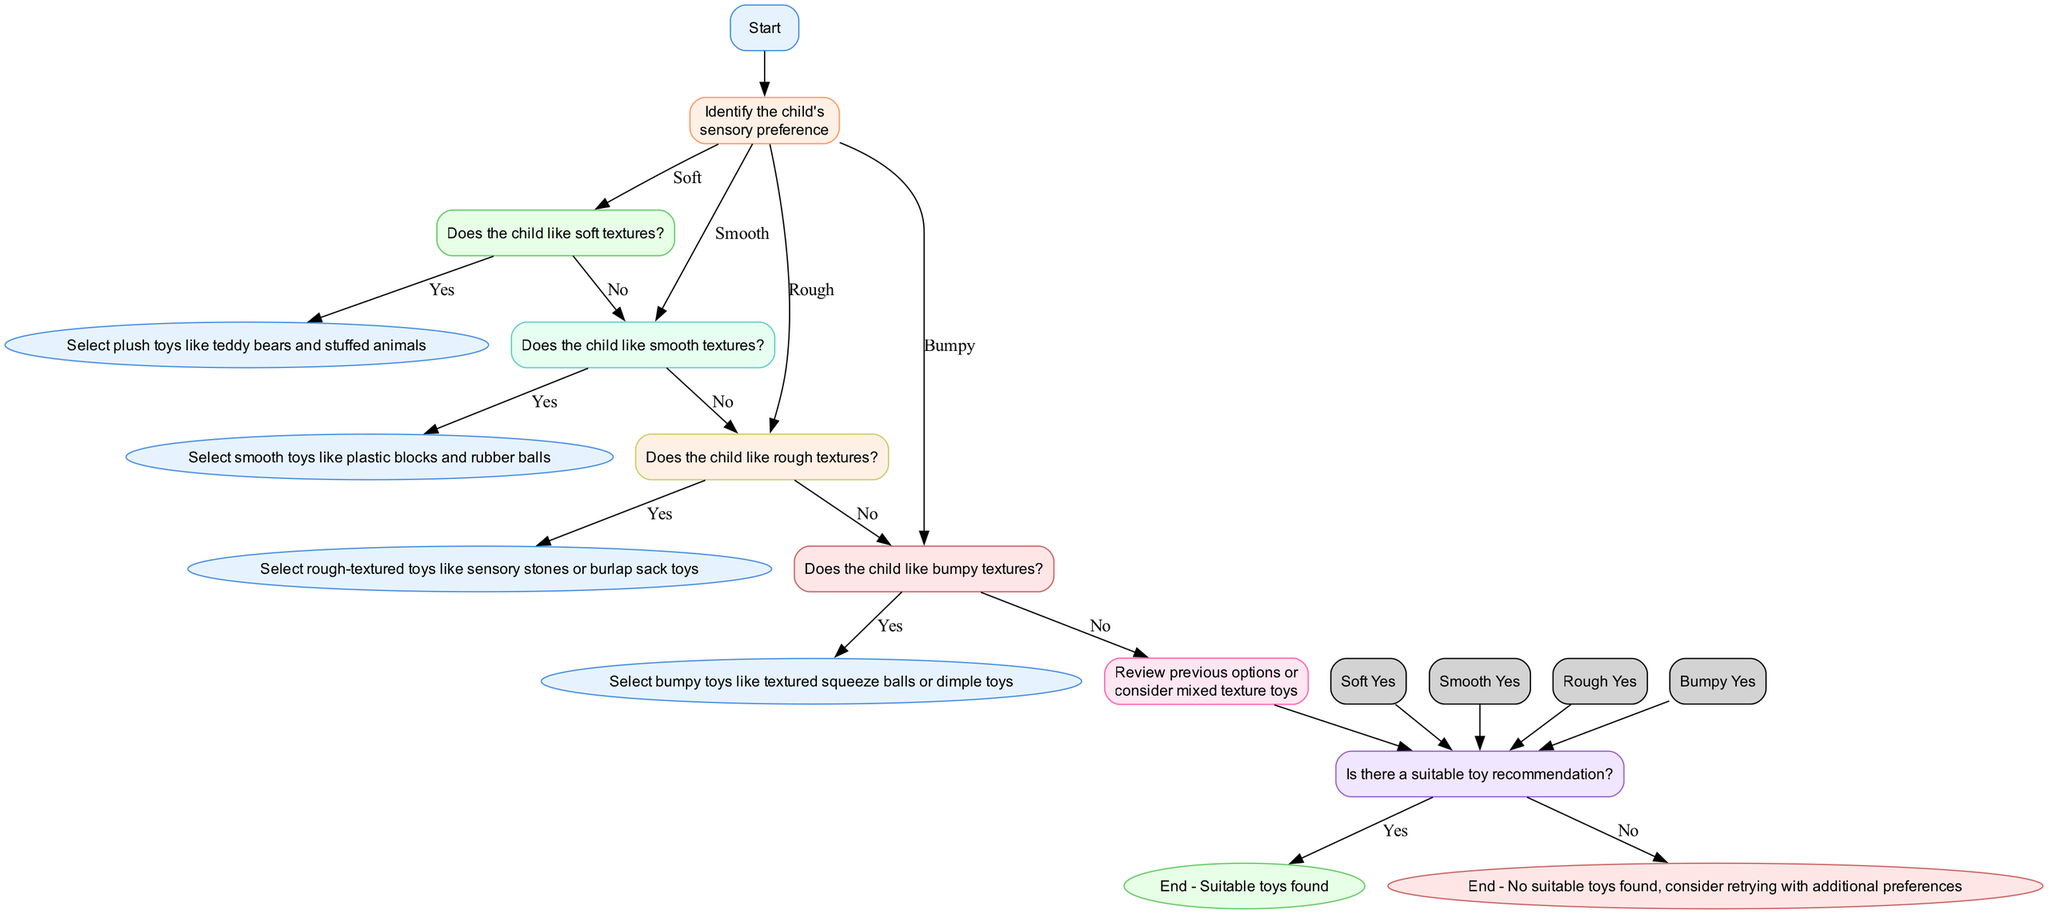What is the first node in the diagram? The first node in the diagram is 'Start', which begins the process of selecting toys based on texture preferences.
Answer: Start How many sensory texture preferences are there? The diagram includes four sensory texture preferences: Soft, Smooth, Rough, and Bumpy. Therefore, there are four preferences.
Answer: Four What happens if the child likes soft textures? If the child likes soft textures, the next step is to select plush toys like teddy bears and stuffed animals.
Answer: Select plush toys What is the next check after the 'Rough' texture check? After checking if the child likes rough textures and answering 'No', the next check will be to see if the child likes bumpy textures.
Answer: Bumpy If the child does not like bumpy textures, what should be done? If the child does not like bumpy textures, the diagram suggests reviewing previous options or considering mixed texture toys as the next step.
Answer: Review previous options or consider mixed texture toys What is the condition to proceed to 'End - Suitable toys found'? To proceed to 'End - Suitable toys found', the recommendation check must indicate 'Yes', implying there is a suitable toy recommendation available.
Answer: Yes Which texture preference leads to the selection of sensory stones or burlap sack toys? The texture preference that leads to the selection of sensory stones or burlap sack toys is 'Rough'.
Answer: Rough What color represents the 'End - No suitable toys found' node? The 'End - No suitable toys found' node is represented in a light pink color (#FFE6E6).
Answer: Light pink What do you do if there are mixed texture toy options? If there are mixed texture toy options, you would review previous options or consider the mixed texture toys as a possible choice.
Answer: Consider mixed texture toys 